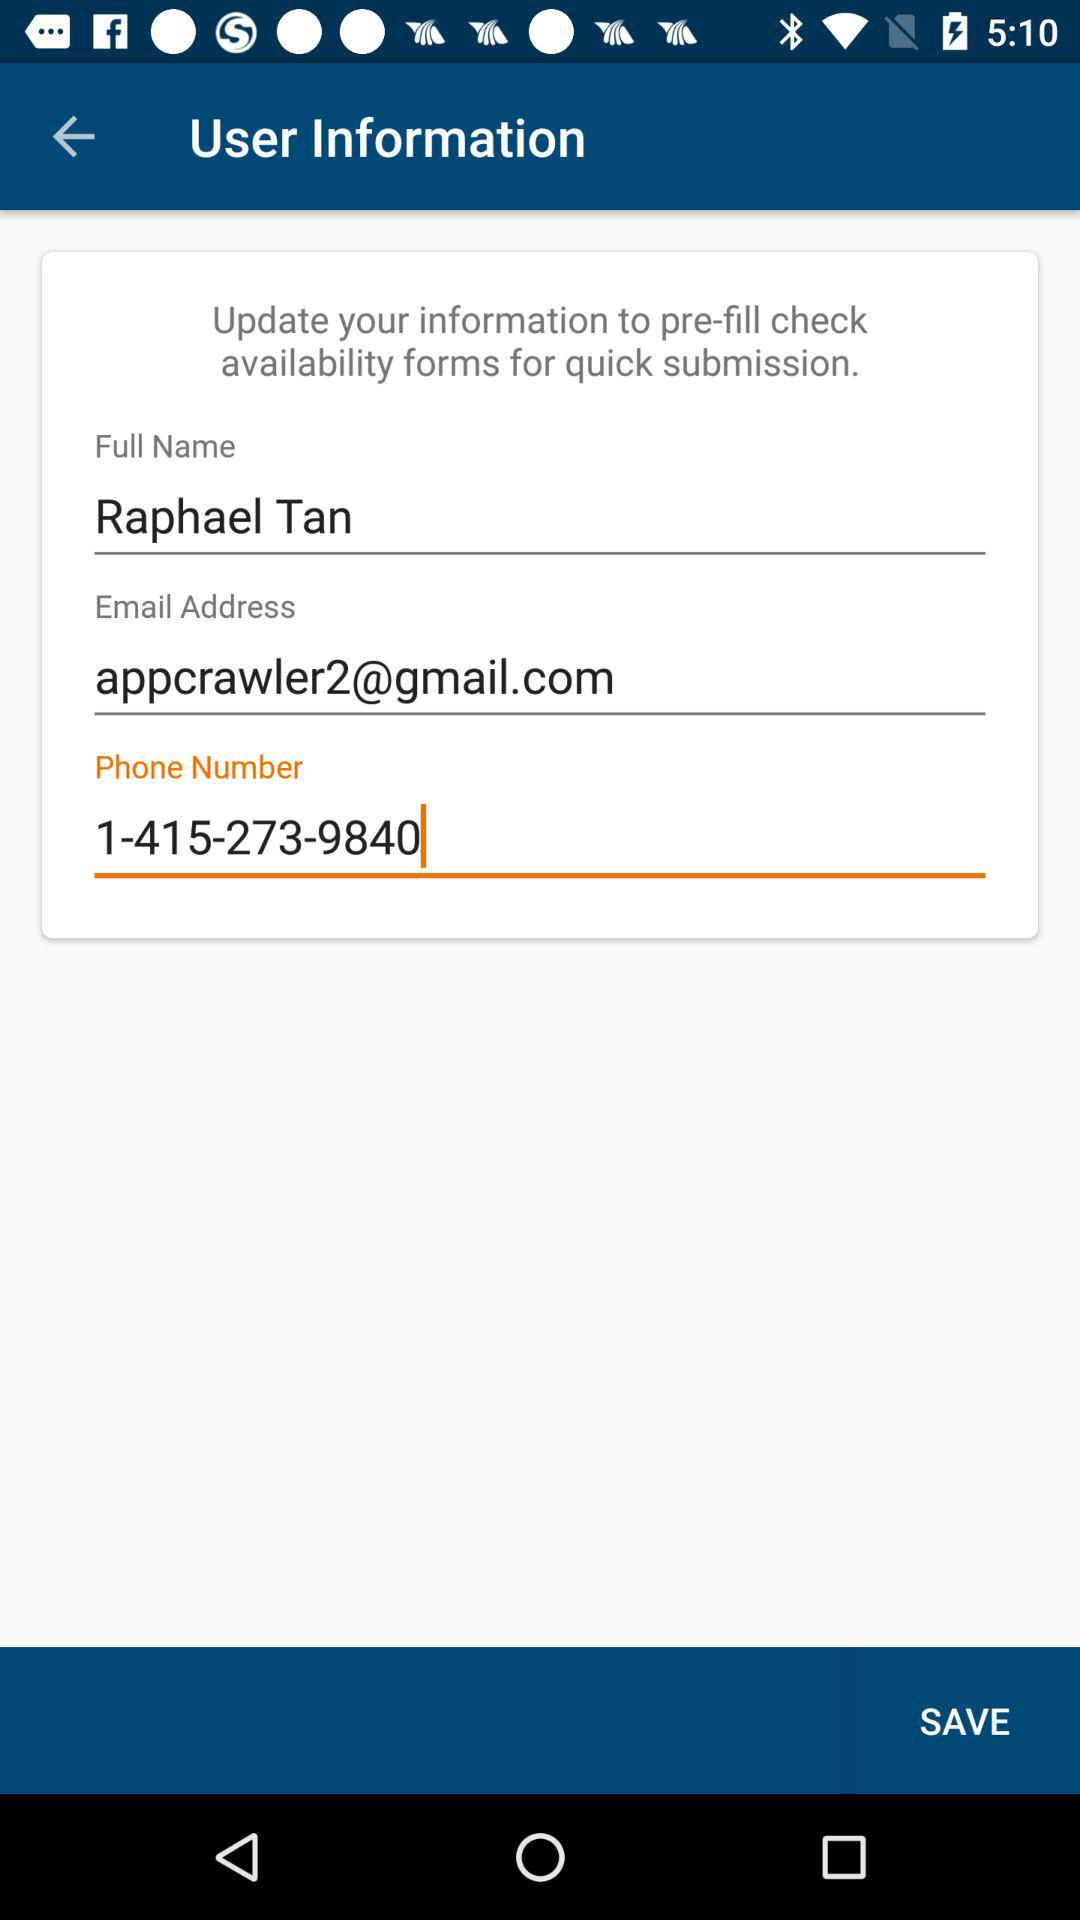What's the email address? The email address is appcrawler2@gmail.com. 